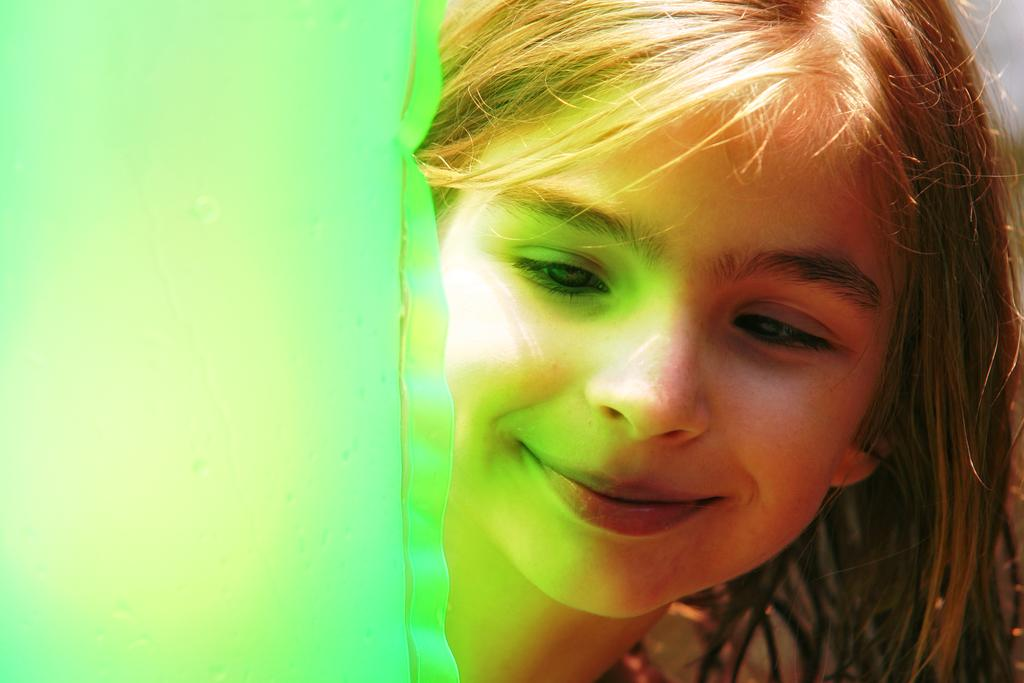What is the main subject of the image? There is a girl in the image. What is the girl's expression in the image? The girl is smiling in the image. What type of operation is being performed on the window in the image? There is no window or operation present in the image; it only features a girl who is smiling. 